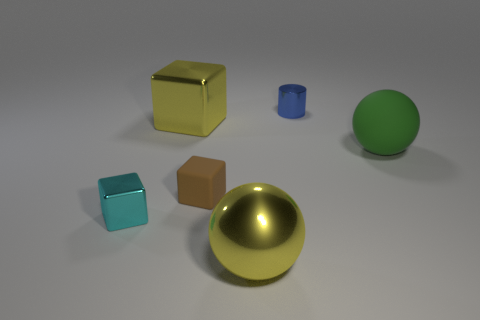There is a ball on the left side of the small blue object; what size is it?
Provide a short and direct response. Large. There is a yellow metal thing behind the large yellow metal object in front of the ball that is on the right side of the shiny cylinder; what size is it?
Make the answer very short. Large. What is the color of the large object that is left of the large sphere to the left of the large rubber object?
Your answer should be compact. Yellow. There is another tiny thing that is the same shape as the tiny brown object; what is its material?
Your answer should be very brief. Metal. Is there anything else that is the same material as the big green ball?
Offer a very short reply. Yes. Are there any large green objects in front of the big yellow shiny sphere?
Your answer should be very brief. No. How many big gray objects are there?
Your answer should be compact. 0. How many big blocks are on the right side of the ball that is behind the yellow shiny sphere?
Provide a short and direct response. 0. There is a tiny rubber thing; is it the same color as the tiny metal thing that is left of the shiny cylinder?
Provide a short and direct response. No. What number of cyan things have the same shape as the brown rubber thing?
Your answer should be very brief. 1. 